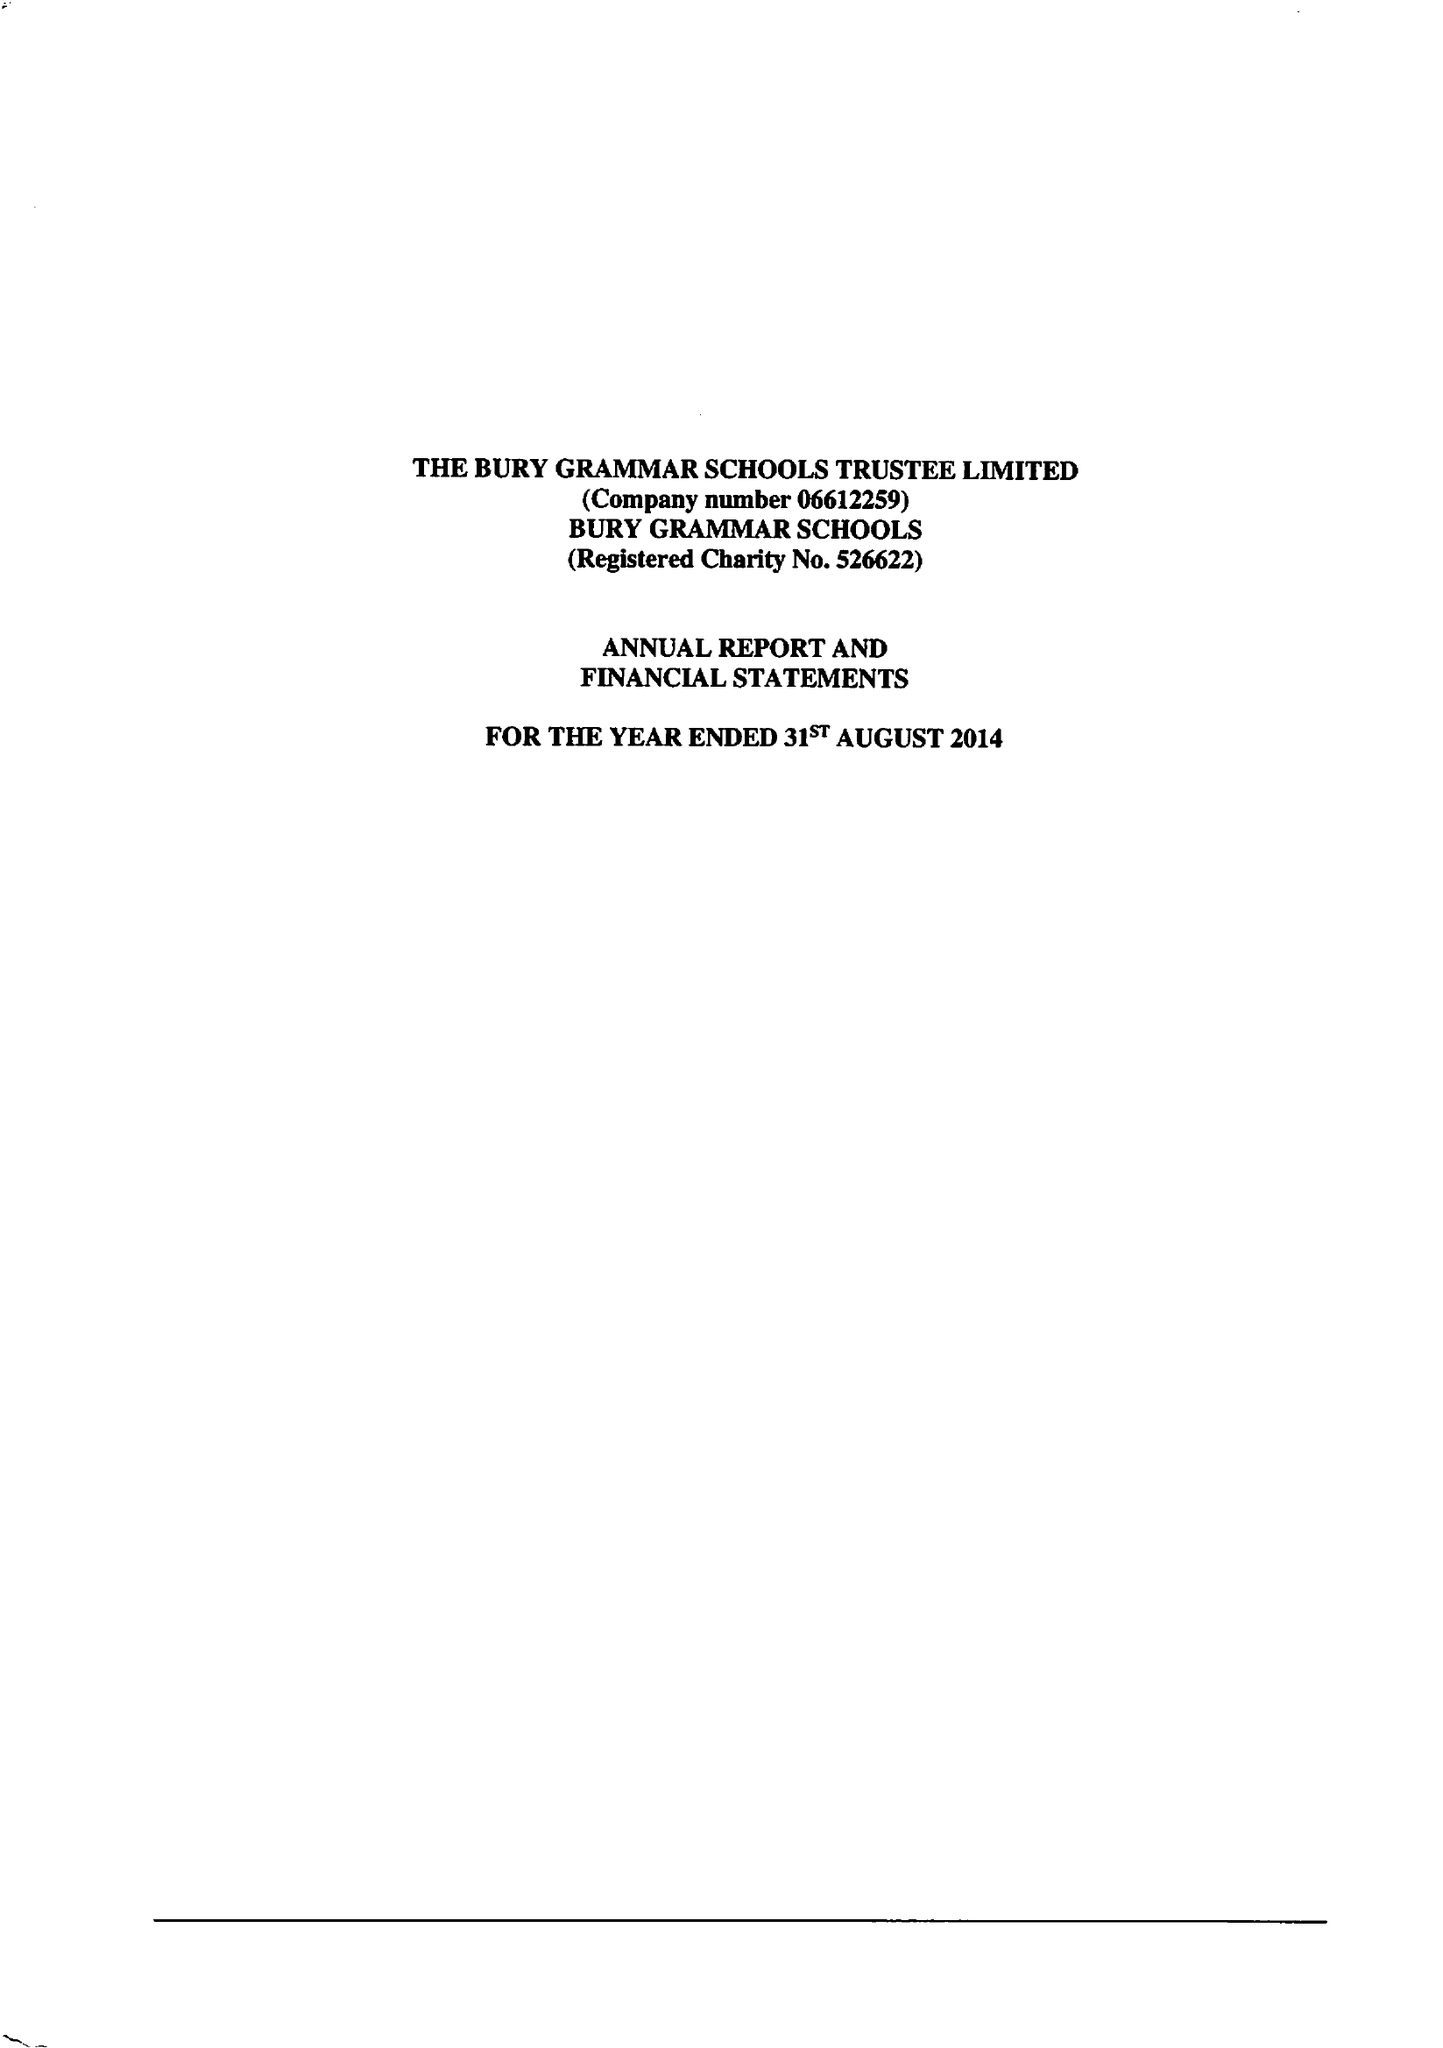What is the value for the spending_annually_in_british_pounds?
Answer the question using a single word or phrase. 12637000.00 